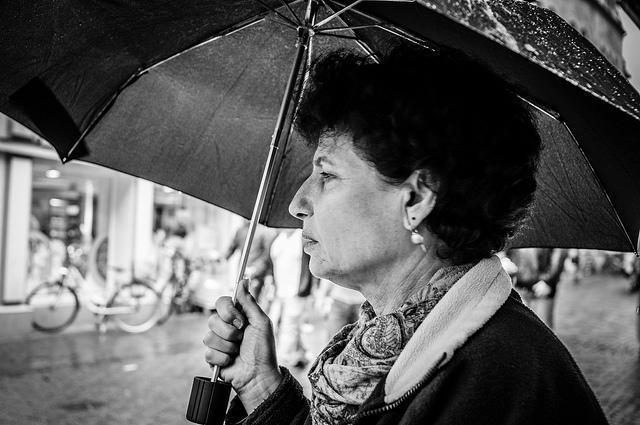What kind of weather is the woman experiencing?
Answer the question by selecting the correct answer among the 4 following choices.
Options: Snow, rain, sleet, wind. Rain. 